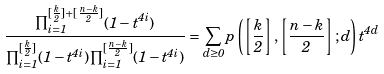Convert formula to latex. <formula><loc_0><loc_0><loc_500><loc_500>\frac { \prod _ { i = 1 } ^ { [ \frac { k } { 2 } ] + [ \frac { n - k } { 2 } ] } ( 1 - t ^ { 4 i } ) } { \prod _ { i = 1 } ^ { [ \frac { k } { 2 } ] } ( 1 - t ^ { 4 i } ) \prod _ { i = 1 } ^ { [ \frac { n - k } { 2 } ] } ( 1 - t ^ { 4 i } ) } = \sum _ { d \geq 0 } p \left ( \left [ \frac { k } { 2 } \right ] , \left [ \frac { n - k } { 2 } \right ] ; d \right ) t ^ { 4 d }</formula> 